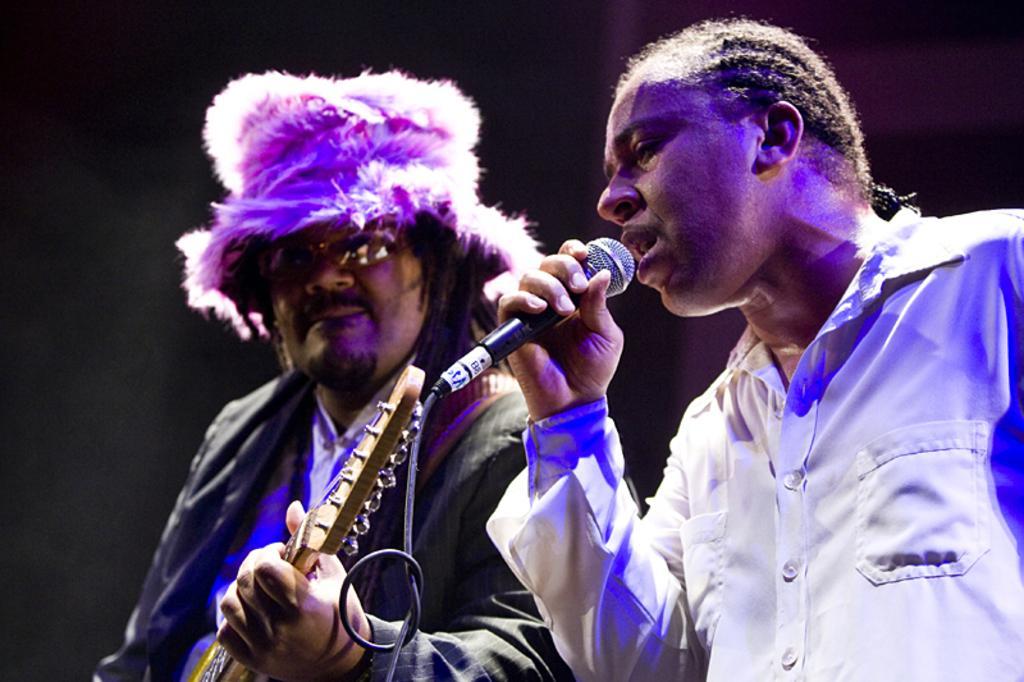Can you describe this image briefly? Here we can see a person standing on the right side. He is holding a microphone in his hand and he is singing on a microphone. There is another person standing on the left side and he is playing a guitar. 